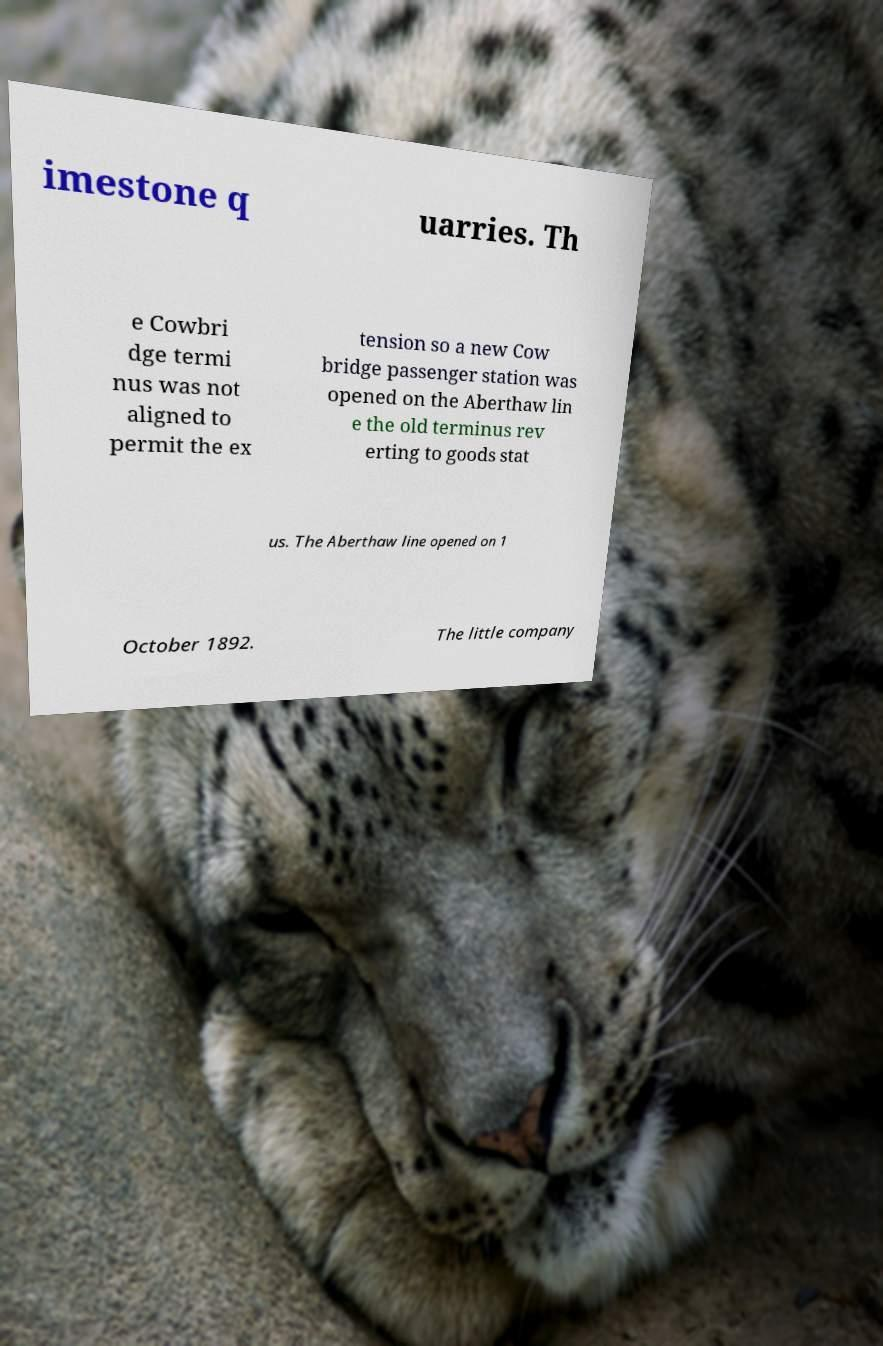Could you extract and type out the text from this image? imestone q uarries. Th e Cowbri dge termi nus was not aligned to permit the ex tension so a new Cow bridge passenger station was opened on the Aberthaw lin e the old terminus rev erting to goods stat us. The Aberthaw line opened on 1 October 1892. The little company 